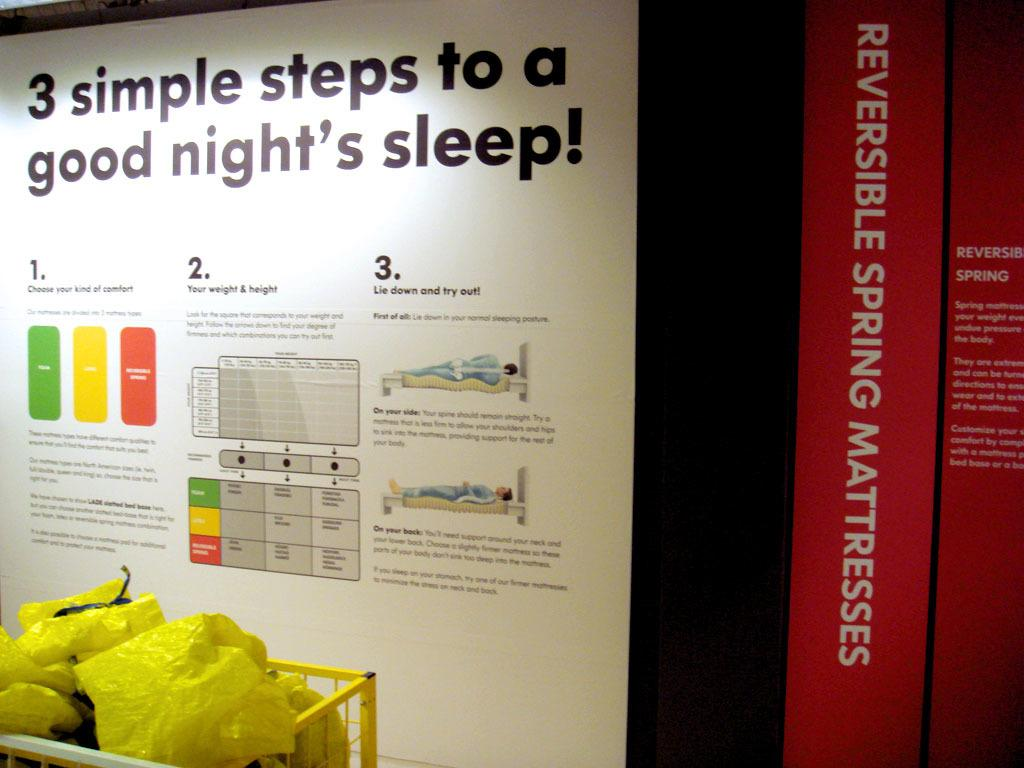<image>
Give a short and clear explanation of the subsequent image. A display entitled "3 simple steps to a good night's sleep!" 